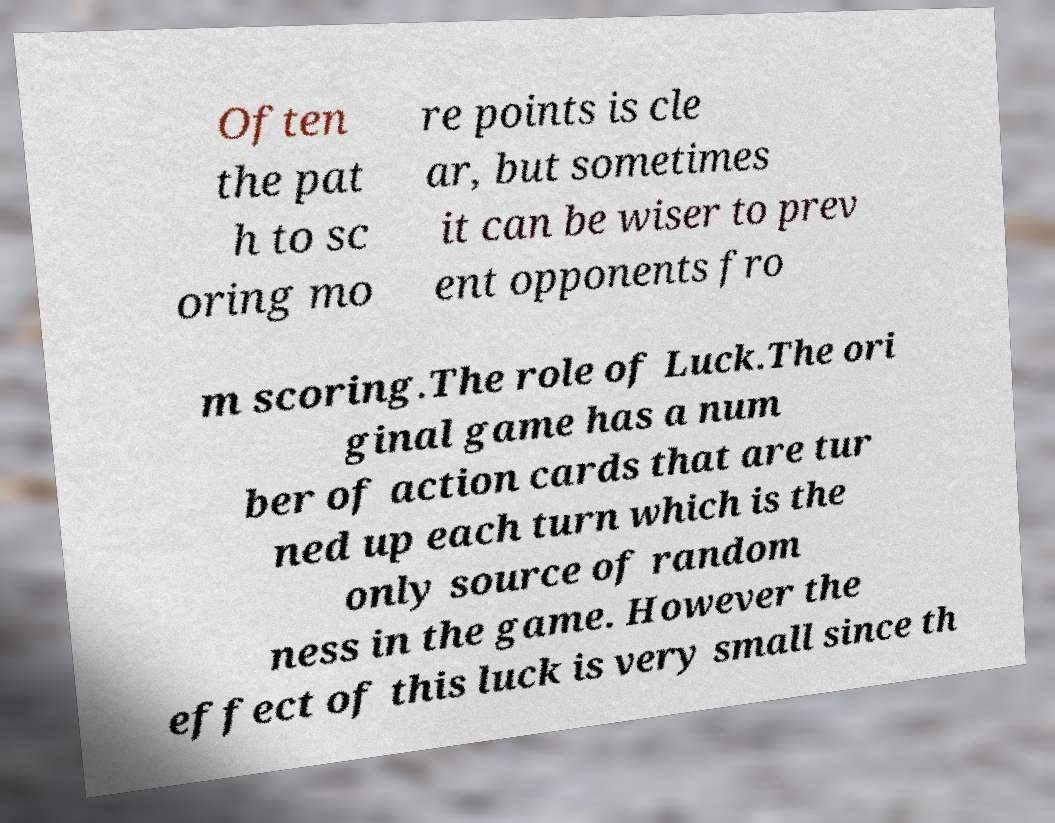Could you assist in decoding the text presented in this image and type it out clearly? Often the pat h to sc oring mo re points is cle ar, but sometimes it can be wiser to prev ent opponents fro m scoring.The role of Luck.The ori ginal game has a num ber of action cards that are tur ned up each turn which is the only source of random ness in the game. However the effect of this luck is very small since th 